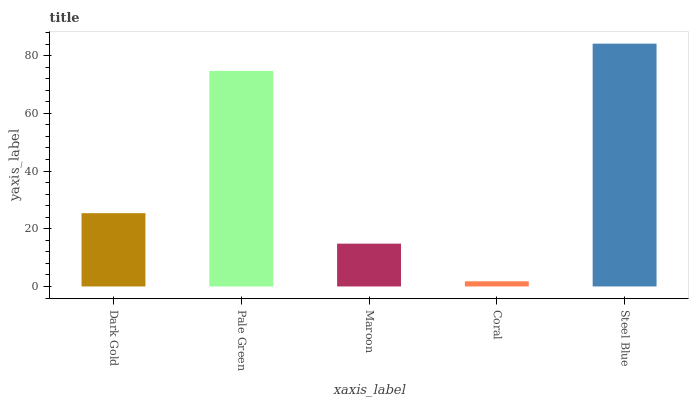Is Coral the minimum?
Answer yes or no. Yes. Is Steel Blue the maximum?
Answer yes or no. Yes. Is Pale Green the minimum?
Answer yes or no. No. Is Pale Green the maximum?
Answer yes or no. No. Is Pale Green greater than Dark Gold?
Answer yes or no. Yes. Is Dark Gold less than Pale Green?
Answer yes or no. Yes. Is Dark Gold greater than Pale Green?
Answer yes or no. No. Is Pale Green less than Dark Gold?
Answer yes or no. No. Is Dark Gold the high median?
Answer yes or no. Yes. Is Dark Gold the low median?
Answer yes or no. Yes. Is Maroon the high median?
Answer yes or no. No. Is Pale Green the low median?
Answer yes or no. No. 